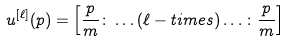Convert formula to latex. <formula><loc_0><loc_0><loc_500><loc_500>u ^ { [ \ell ] } ( p ) = \left [ \frac { p } { m } \colon \dots ( \ell - t i m e s ) \dots \colon \frac { p } { m } \right ]</formula> 